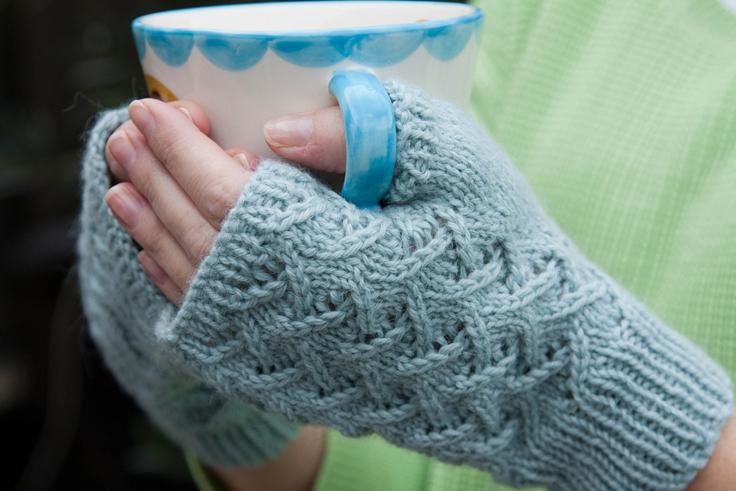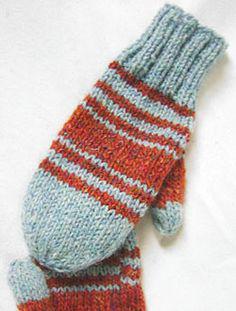The first image is the image on the left, the second image is the image on the right. For the images shown, is this caption "Both images have gloves over a white background." true? Answer yes or no. No. 